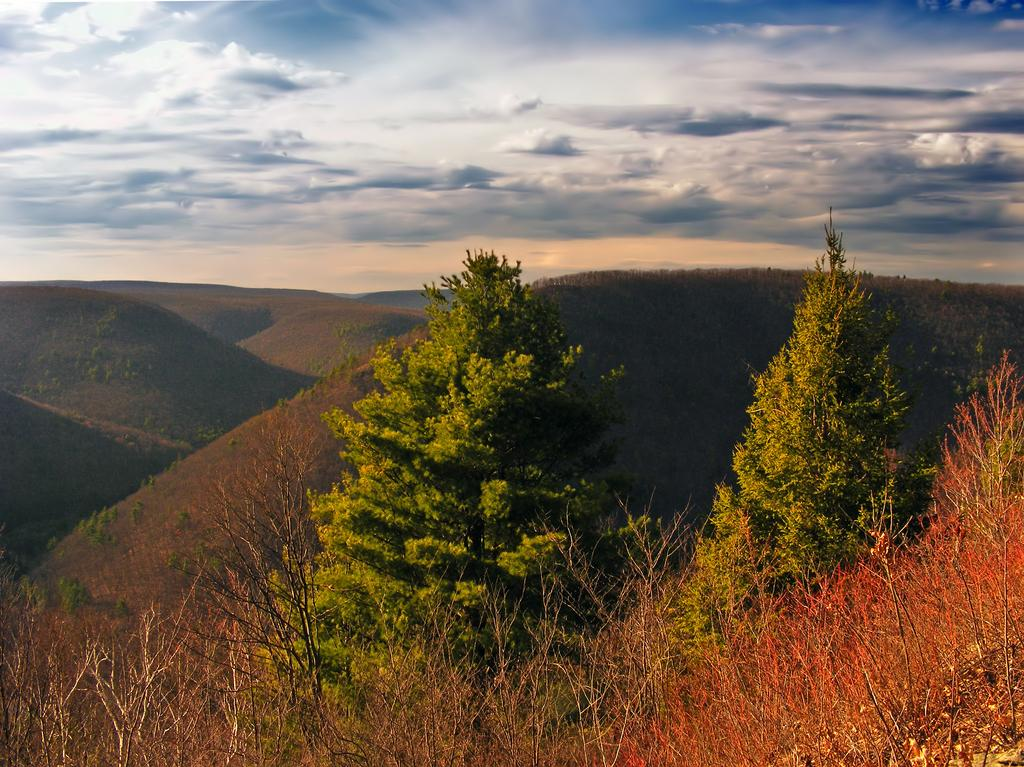What is the condition of the sky in the image? The sky in the image is clouded. What type of natural formation can be seen in the image? There are mountains visible in the image. How many trees are present in the image? There are two trees in the image. What type of vegetation is present at the bottom of the image? There are plants at the bottom of the image. What time does the clock show in the image? There is no clock present in the image. How does the person in the image point at the mountains? There is no person present in the image. What type of wind can be seen blowing in the image? There is no wind or blowing action depicted in the image. 